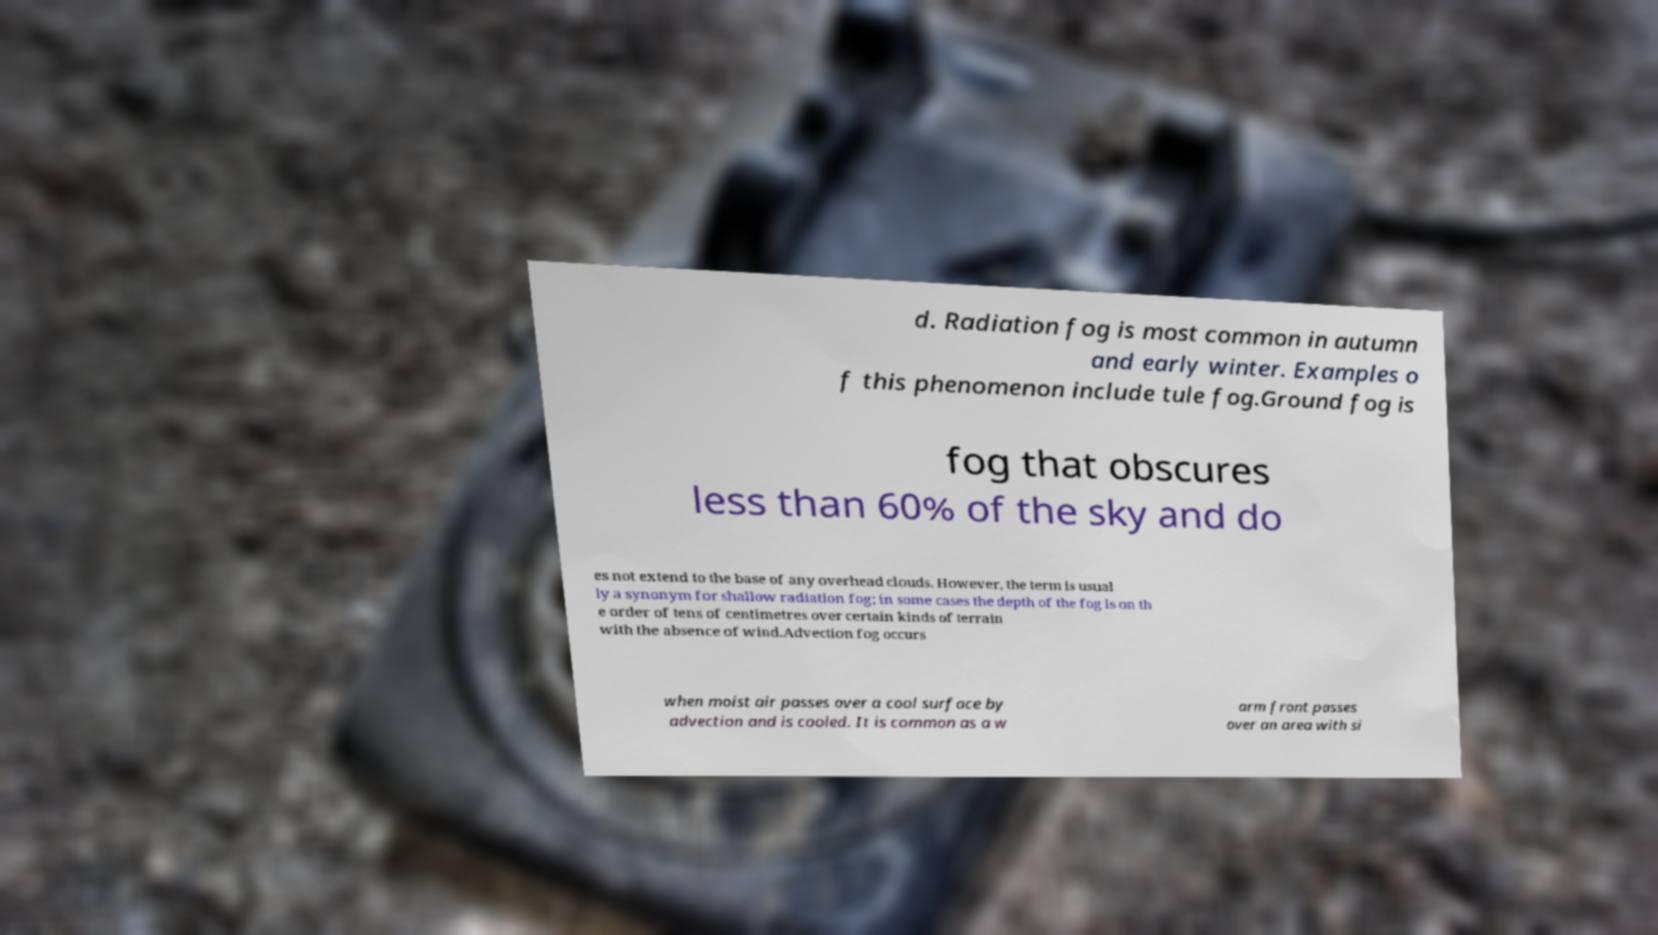Could you assist in decoding the text presented in this image and type it out clearly? d. Radiation fog is most common in autumn and early winter. Examples o f this phenomenon include tule fog.Ground fog is fog that obscures less than 60% of the sky and do es not extend to the base of any overhead clouds. However, the term is usual ly a synonym for shallow radiation fog; in some cases the depth of the fog is on th e order of tens of centimetres over certain kinds of terrain with the absence of wind.Advection fog occurs when moist air passes over a cool surface by advection and is cooled. It is common as a w arm front passes over an area with si 